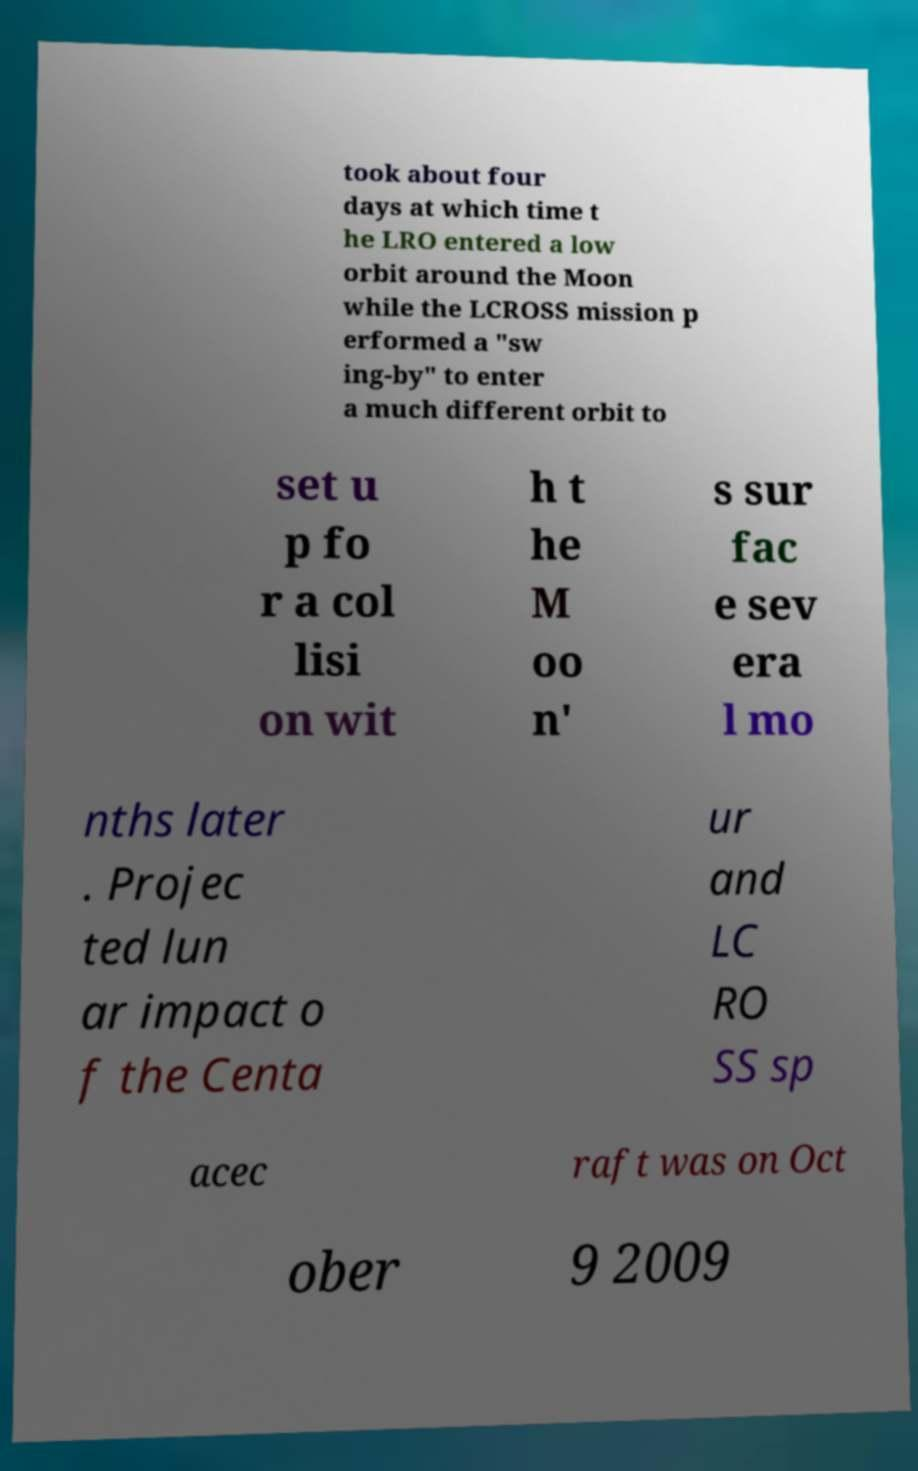I need the written content from this picture converted into text. Can you do that? took about four days at which time t he LRO entered a low orbit around the Moon while the LCROSS mission p erformed a "sw ing-by" to enter a much different orbit to set u p fo r a col lisi on wit h t he M oo n' s sur fac e sev era l mo nths later . Projec ted lun ar impact o f the Centa ur and LC RO SS sp acec raft was on Oct ober 9 2009 